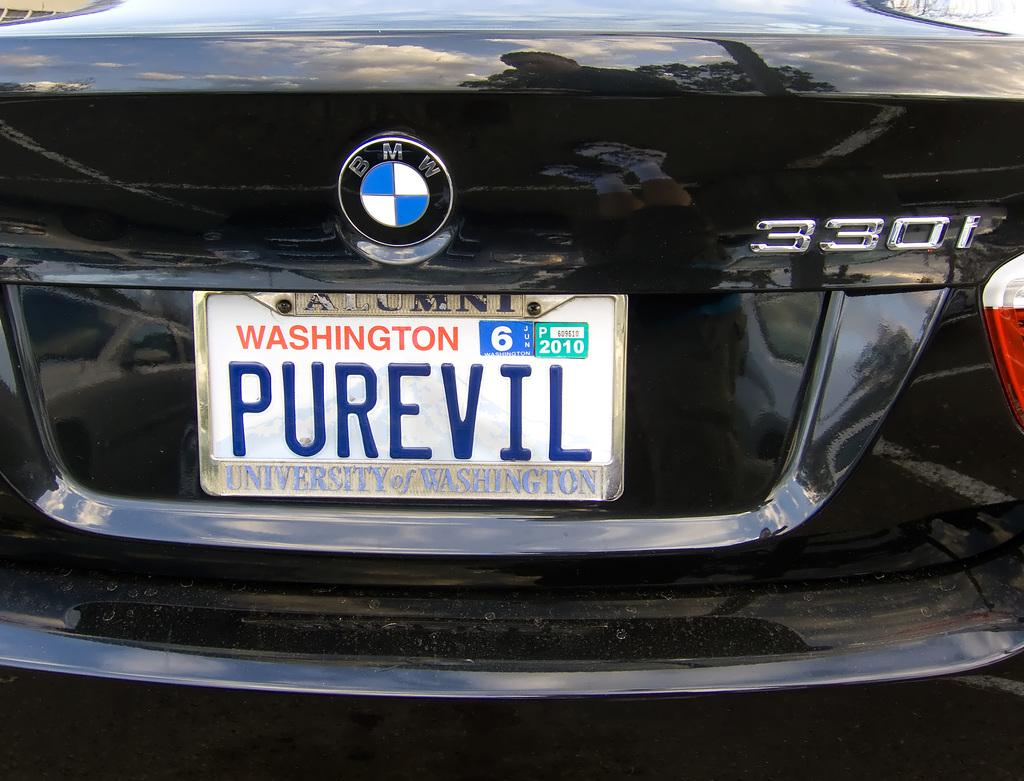<image>
Summarize the visual content of the image. A Washington state plate for a BMW reads PUREVIL. 